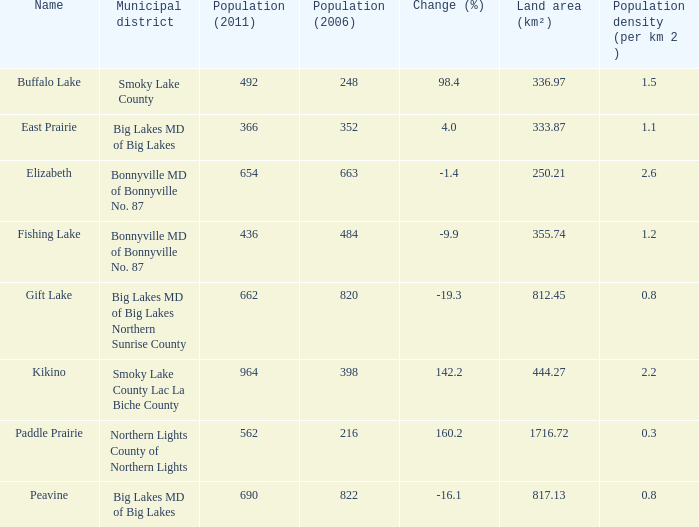What is the population per km2 in Fishing Lake? 1.2. 